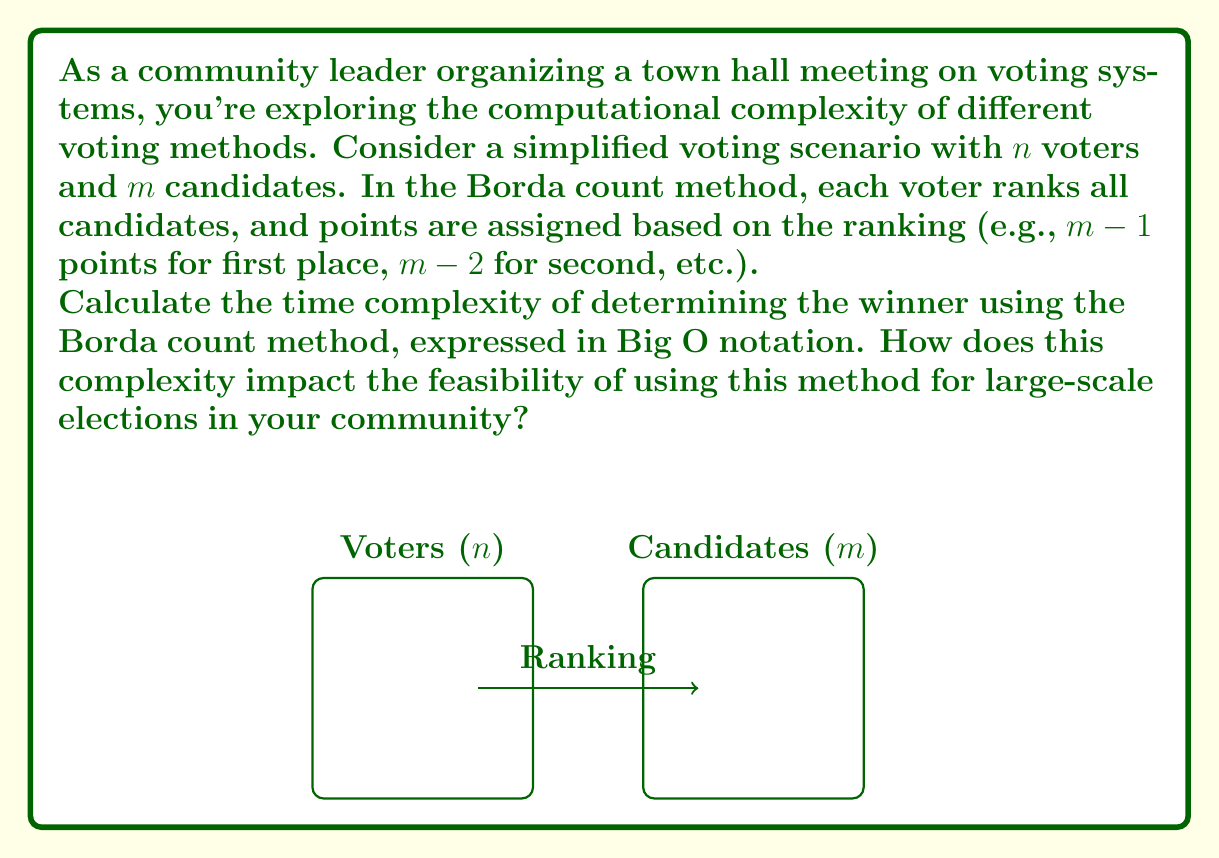Teach me how to tackle this problem. To determine the time complexity of the Borda count method, let's break down the process:

1. Each voter must rank all $m$ candidates. This requires $O(m)$ operations per voter.

2. There are $n$ voters, so the total complexity for ranking is $O(nm)$.

3. For each candidate, we need to sum up their points from all voters:
   - Each voter contributes one value to each candidate's total.
   - There are $n$ voters and $m$ candidates.
   - This summation process has a complexity of $O(nm)$.

4. Finally, we need to find the maximum score among the $m$ candidates, which is $O(m)$.

The overall time complexity is the sum of these steps:

$$O(nm) + O(nm) + O(m) = O(nm)$$

The dominant term is $O(nm)$, which represents the time complexity of the Borda count method.

Impact on feasibility:
- For small to medium-sized elections (e.g., town or city level), this complexity is manageable.
- As $n$ and $m$ grow larger (e.g., national elections), the computational time increases quadratically.
- This could lead to delays in determining results for very large elections.
- It may necessitate significant computational resources for timely results in large-scale implementations.

The complexity also impacts the ability to quickly recount or verify results, which could be crucial for ensuring fair representation and maintaining public trust in the voting system.
Answer: $O(nm)$ 